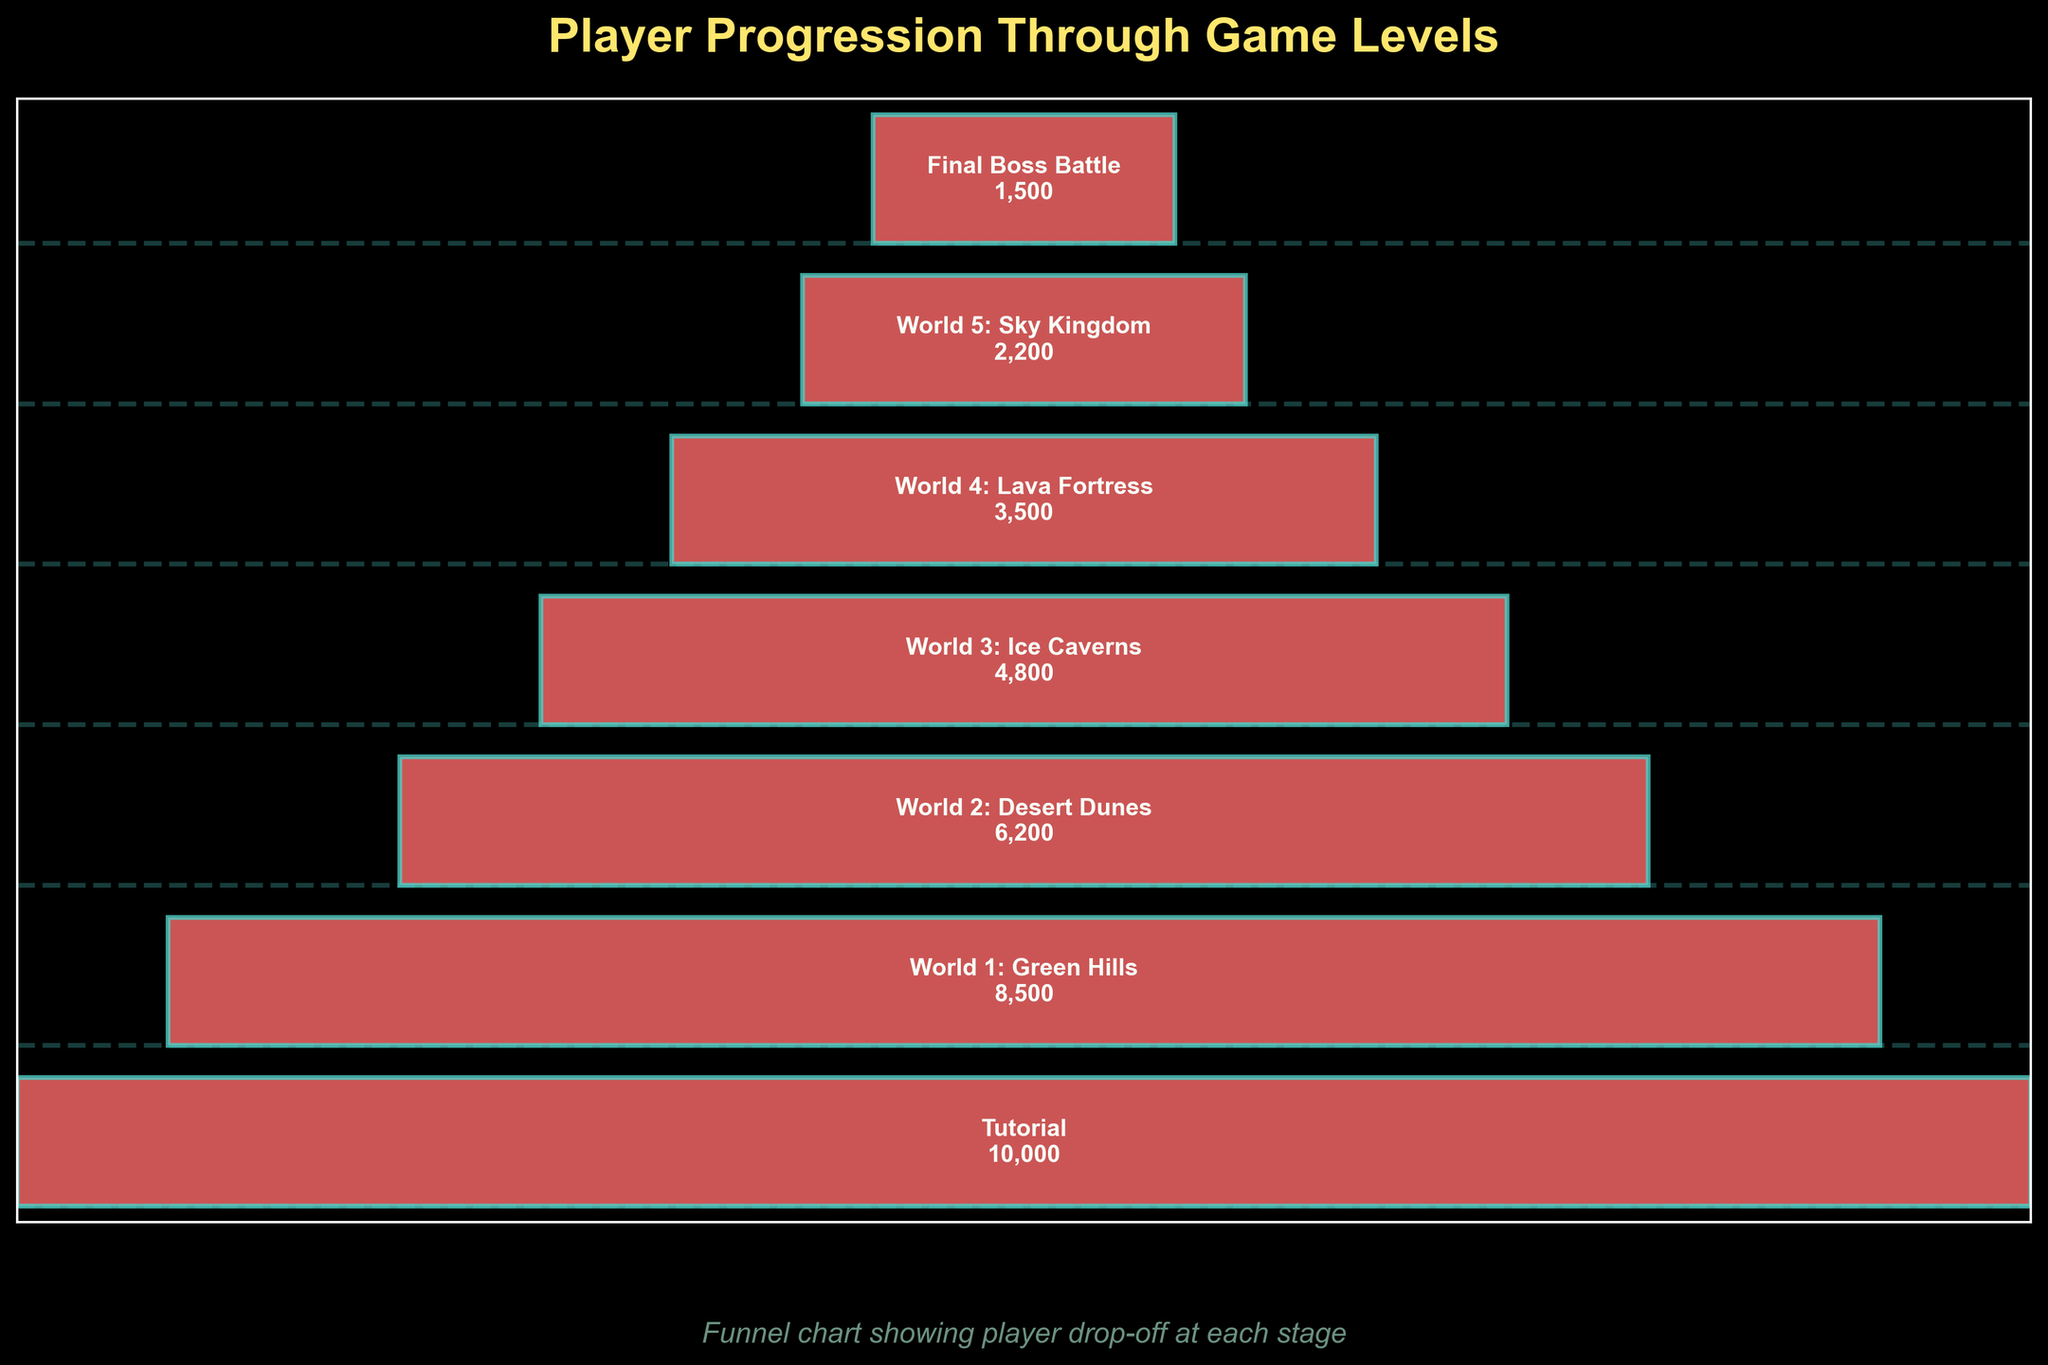What is the title of the chart? The title of the chart is written at the top and provides an overview of what the chart represents.
Answer: Player Progression Through Game Levels How many players started the tutorial stage? The number of players for the initial stage (Tutorial) is given directly next to the corresponding label.
Answer: 10,000 At which stage is the player drop-off the highest? To find the highest drop-off, compare the difference in the number of players between each consecutive stage and find the largest decrease. The drop-off from "World 1: Green Hills" to "World 2: Desert Dunes" is 2,300 players (8,500 - 6,200), which is the largest drop-off.
Answer: World 1: Green Hills Compare the number of players in World 3: Ice Caverns and World 4: Lava Fortress. Are there more players in World 3 or World 4? Look at the number of players for both stages and compare. World 3: Ice Caverns has 4,800 players, whereas World 4: Lava Fortress has 3,500 players.
Answer: World 3: Ice Caverns What is the average number of players remaining after each stage, excluding the tutorial stage? The stages excluding the tutorial are: World 1 through the Final Boss Battle. The number of players for these stages are 8,500, 6,200, 4,800, 3,500, 2,200, and 1,500. Calculate the average: (8,500 + 6,200 + 4,800 + 3,500 + 2,200 + 1,500) / 6 = 26,700 / 6 = 4,450
Answer: 4,450 If 1,000 more players had continued from World 3: Ice Caverns to World 4: Lava Fortress, how many players would be in World 4? The current number of players in World 4 is 3,500. Add 1,000 to this number for the new total.
Answer: 4,500 How many stages are represented in the funnel chart? Count the unique stages listed along the y-axis.
Answer: 7 What is the total drop-off from the Tutorial stage to the Final Boss Battle? Subtract the number of players in the Final Boss Battle from those in the Tutorial stage. 10,000 (Tutorial) - 1,500 (Final Boss Battle) = 8,500
Answer: 8,500 What is the median number of players across all stages? Arrange the player counts in ascending order: 1,500, 2,200, 3,500, 4,800, 6,200, 8,500, 10,000. The median is the middle value, which is 4,800.
Answer: 4,800 